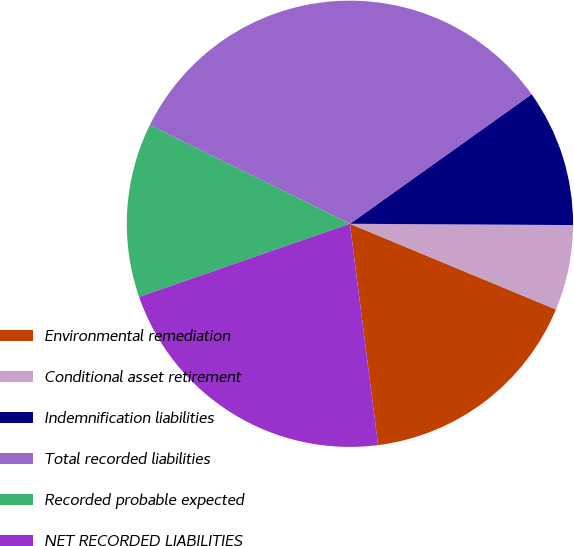<chart> <loc_0><loc_0><loc_500><loc_500><pie_chart><fcel>Environmental remediation<fcel>Conditional asset retirement<fcel>Indemnification liabilities<fcel>Total recorded liabilities<fcel>Recorded probable expected<fcel>NET RECORDED LIABILITIES<nl><fcel>16.71%<fcel>6.18%<fcel>9.95%<fcel>32.84%<fcel>12.61%<fcel>21.7%<nl></chart> 